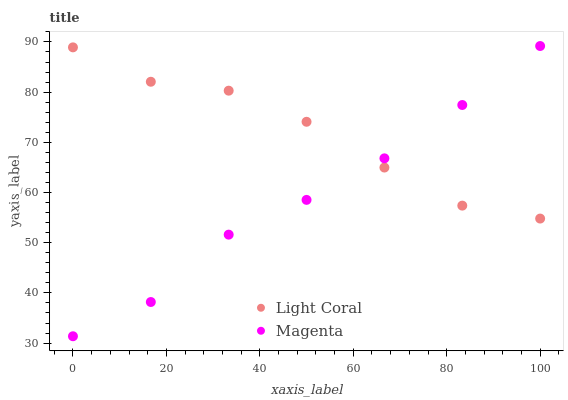Does Magenta have the minimum area under the curve?
Answer yes or no. Yes. Does Light Coral have the maximum area under the curve?
Answer yes or no. Yes. Does Magenta have the maximum area under the curve?
Answer yes or no. No. Is Magenta the smoothest?
Answer yes or no. Yes. Is Light Coral the roughest?
Answer yes or no. Yes. Is Magenta the roughest?
Answer yes or no. No. Does Magenta have the lowest value?
Answer yes or no. Yes. Does Magenta have the highest value?
Answer yes or no. Yes. Does Light Coral intersect Magenta?
Answer yes or no. Yes. Is Light Coral less than Magenta?
Answer yes or no. No. Is Light Coral greater than Magenta?
Answer yes or no. No. 